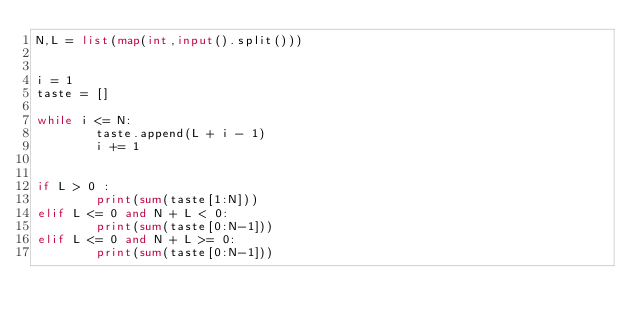<code> <loc_0><loc_0><loc_500><loc_500><_Python_>N,L = list(map(int,input().split()))


i = 1
taste = []

while i <= N:
        taste.append(L + i - 1)
        i += 1


if L > 0 :
        print(sum(taste[1:N]))
elif L <= 0 and N + L < 0:
        print(sum(taste[0:N-1]))
elif L <= 0 and N + L >= 0:
        print(sum(taste[0:N-1]))</code> 